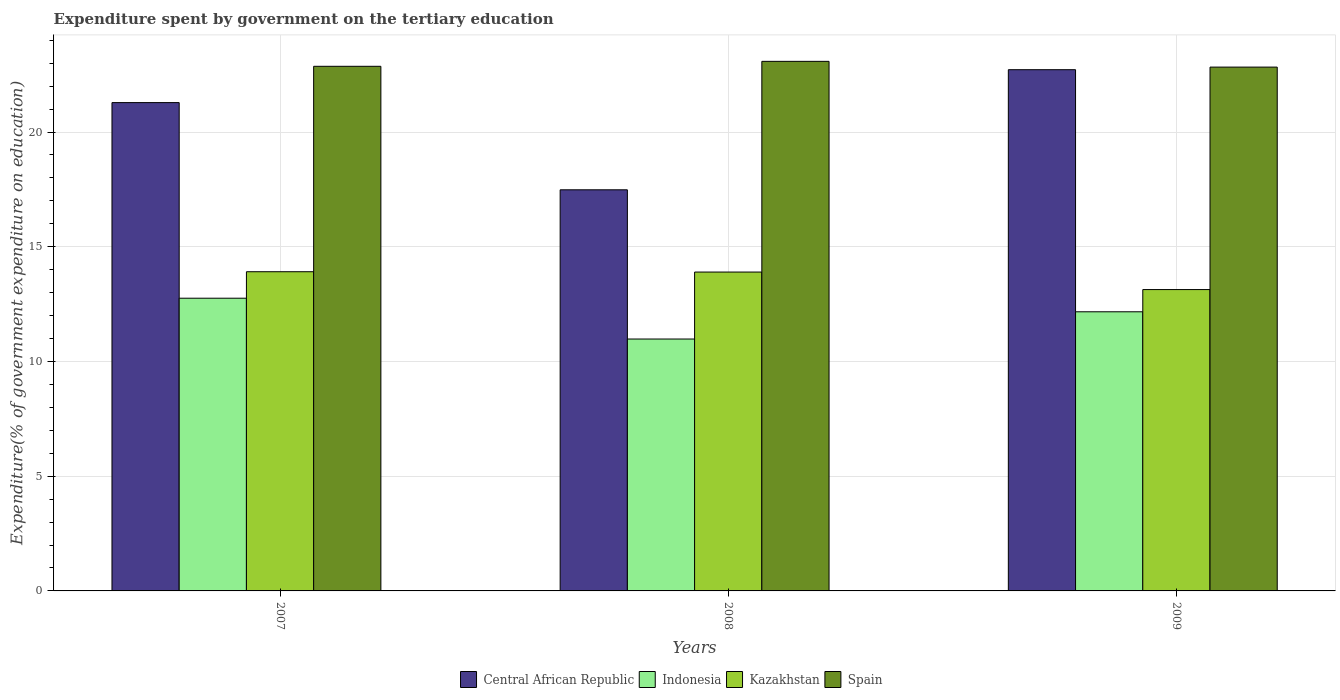How many different coloured bars are there?
Provide a short and direct response. 4. How many groups of bars are there?
Give a very brief answer. 3. Are the number of bars per tick equal to the number of legend labels?
Provide a short and direct response. Yes. Are the number of bars on each tick of the X-axis equal?
Provide a short and direct response. Yes. What is the label of the 2nd group of bars from the left?
Provide a short and direct response. 2008. What is the expenditure spent by government on the tertiary education in Spain in 2007?
Your answer should be very brief. 22.86. Across all years, what is the maximum expenditure spent by government on the tertiary education in Indonesia?
Your answer should be very brief. 12.76. Across all years, what is the minimum expenditure spent by government on the tertiary education in Kazakhstan?
Offer a terse response. 13.13. In which year was the expenditure spent by government on the tertiary education in Kazakhstan maximum?
Provide a succinct answer. 2007. In which year was the expenditure spent by government on the tertiary education in Spain minimum?
Provide a succinct answer. 2009. What is the total expenditure spent by government on the tertiary education in Spain in the graph?
Your answer should be very brief. 68.77. What is the difference between the expenditure spent by government on the tertiary education in Indonesia in 2007 and that in 2008?
Give a very brief answer. 1.78. What is the difference between the expenditure spent by government on the tertiary education in Kazakhstan in 2007 and the expenditure spent by government on the tertiary education in Spain in 2009?
Your answer should be compact. -8.92. What is the average expenditure spent by government on the tertiary education in Spain per year?
Your answer should be compact. 22.92. In the year 2009, what is the difference between the expenditure spent by government on the tertiary education in Indonesia and expenditure spent by government on the tertiary education in Spain?
Your answer should be very brief. -10.66. In how many years, is the expenditure spent by government on the tertiary education in Kazakhstan greater than 21 %?
Provide a succinct answer. 0. What is the ratio of the expenditure spent by government on the tertiary education in Spain in 2007 to that in 2009?
Offer a very short reply. 1. Is the expenditure spent by government on the tertiary education in Indonesia in 2008 less than that in 2009?
Your answer should be compact. Yes. Is the difference between the expenditure spent by government on the tertiary education in Indonesia in 2008 and 2009 greater than the difference between the expenditure spent by government on the tertiary education in Spain in 2008 and 2009?
Give a very brief answer. No. What is the difference between the highest and the second highest expenditure spent by government on the tertiary education in Spain?
Make the answer very short. 0.22. What is the difference between the highest and the lowest expenditure spent by government on the tertiary education in Central African Republic?
Your answer should be compact. 5.23. In how many years, is the expenditure spent by government on the tertiary education in Indonesia greater than the average expenditure spent by government on the tertiary education in Indonesia taken over all years?
Give a very brief answer. 2. Is the sum of the expenditure spent by government on the tertiary education in Spain in 2008 and 2009 greater than the maximum expenditure spent by government on the tertiary education in Central African Republic across all years?
Make the answer very short. Yes. Is it the case that in every year, the sum of the expenditure spent by government on the tertiary education in Kazakhstan and expenditure spent by government on the tertiary education in Spain is greater than the sum of expenditure spent by government on the tertiary education in Central African Republic and expenditure spent by government on the tertiary education in Indonesia?
Provide a short and direct response. No. What does the 4th bar from the left in 2008 represents?
Give a very brief answer. Spain. Are all the bars in the graph horizontal?
Your response must be concise. No. Does the graph contain any zero values?
Give a very brief answer. No. How many legend labels are there?
Keep it short and to the point. 4. How are the legend labels stacked?
Your answer should be very brief. Horizontal. What is the title of the graph?
Make the answer very short. Expenditure spent by government on the tertiary education. Does "Mexico" appear as one of the legend labels in the graph?
Your response must be concise. No. What is the label or title of the Y-axis?
Your answer should be compact. Expenditure(% of government expenditure on education). What is the Expenditure(% of government expenditure on education) in Central African Republic in 2007?
Give a very brief answer. 21.28. What is the Expenditure(% of government expenditure on education) of Indonesia in 2007?
Give a very brief answer. 12.76. What is the Expenditure(% of government expenditure on education) in Kazakhstan in 2007?
Offer a terse response. 13.91. What is the Expenditure(% of government expenditure on education) of Spain in 2007?
Offer a terse response. 22.86. What is the Expenditure(% of government expenditure on education) in Central African Republic in 2008?
Offer a very short reply. 17.48. What is the Expenditure(% of government expenditure on education) of Indonesia in 2008?
Provide a short and direct response. 10.98. What is the Expenditure(% of government expenditure on education) in Kazakhstan in 2008?
Make the answer very short. 13.9. What is the Expenditure(% of government expenditure on education) of Spain in 2008?
Your response must be concise. 23.08. What is the Expenditure(% of government expenditure on education) in Central African Republic in 2009?
Your answer should be very brief. 22.72. What is the Expenditure(% of government expenditure on education) in Indonesia in 2009?
Provide a short and direct response. 12.17. What is the Expenditure(% of government expenditure on education) of Kazakhstan in 2009?
Your response must be concise. 13.13. What is the Expenditure(% of government expenditure on education) in Spain in 2009?
Your response must be concise. 22.83. Across all years, what is the maximum Expenditure(% of government expenditure on education) in Central African Republic?
Keep it short and to the point. 22.72. Across all years, what is the maximum Expenditure(% of government expenditure on education) in Indonesia?
Offer a terse response. 12.76. Across all years, what is the maximum Expenditure(% of government expenditure on education) in Kazakhstan?
Provide a short and direct response. 13.91. Across all years, what is the maximum Expenditure(% of government expenditure on education) in Spain?
Give a very brief answer. 23.08. Across all years, what is the minimum Expenditure(% of government expenditure on education) of Central African Republic?
Give a very brief answer. 17.48. Across all years, what is the minimum Expenditure(% of government expenditure on education) in Indonesia?
Keep it short and to the point. 10.98. Across all years, what is the minimum Expenditure(% of government expenditure on education) in Kazakhstan?
Ensure brevity in your answer.  13.13. Across all years, what is the minimum Expenditure(% of government expenditure on education) in Spain?
Offer a terse response. 22.83. What is the total Expenditure(% of government expenditure on education) of Central African Republic in the graph?
Provide a short and direct response. 61.48. What is the total Expenditure(% of government expenditure on education) in Indonesia in the graph?
Your answer should be very brief. 35.9. What is the total Expenditure(% of government expenditure on education) of Kazakhstan in the graph?
Ensure brevity in your answer.  40.94. What is the total Expenditure(% of government expenditure on education) in Spain in the graph?
Give a very brief answer. 68.77. What is the difference between the Expenditure(% of government expenditure on education) of Central African Republic in 2007 and that in 2008?
Offer a very short reply. 3.8. What is the difference between the Expenditure(% of government expenditure on education) in Indonesia in 2007 and that in 2008?
Provide a short and direct response. 1.78. What is the difference between the Expenditure(% of government expenditure on education) of Kazakhstan in 2007 and that in 2008?
Offer a terse response. 0.01. What is the difference between the Expenditure(% of government expenditure on education) of Spain in 2007 and that in 2008?
Your response must be concise. -0.22. What is the difference between the Expenditure(% of government expenditure on education) in Central African Republic in 2007 and that in 2009?
Ensure brevity in your answer.  -1.43. What is the difference between the Expenditure(% of government expenditure on education) of Indonesia in 2007 and that in 2009?
Your answer should be very brief. 0.59. What is the difference between the Expenditure(% of government expenditure on education) of Kazakhstan in 2007 and that in 2009?
Keep it short and to the point. 0.78. What is the difference between the Expenditure(% of government expenditure on education) in Spain in 2007 and that in 2009?
Make the answer very short. 0.03. What is the difference between the Expenditure(% of government expenditure on education) in Central African Republic in 2008 and that in 2009?
Make the answer very short. -5.23. What is the difference between the Expenditure(% of government expenditure on education) of Indonesia in 2008 and that in 2009?
Your answer should be very brief. -1.19. What is the difference between the Expenditure(% of government expenditure on education) of Kazakhstan in 2008 and that in 2009?
Keep it short and to the point. 0.76. What is the difference between the Expenditure(% of government expenditure on education) of Spain in 2008 and that in 2009?
Your answer should be very brief. 0.25. What is the difference between the Expenditure(% of government expenditure on education) in Central African Republic in 2007 and the Expenditure(% of government expenditure on education) in Indonesia in 2008?
Ensure brevity in your answer.  10.3. What is the difference between the Expenditure(% of government expenditure on education) in Central African Republic in 2007 and the Expenditure(% of government expenditure on education) in Kazakhstan in 2008?
Ensure brevity in your answer.  7.39. What is the difference between the Expenditure(% of government expenditure on education) of Central African Republic in 2007 and the Expenditure(% of government expenditure on education) of Spain in 2008?
Offer a very short reply. -1.8. What is the difference between the Expenditure(% of government expenditure on education) in Indonesia in 2007 and the Expenditure(% of government expenditure on education) in Kazakhstan in 2008?
Offer a very short reply. -1.14. What is the difference between the Expenditure(% of government expenditure on education) of Indonesia in 2007 and the Expenditure(% of government expenditure on education) of Spain in 2008?
Keep it short and to the point. -10.32. What is the difference between the Expenditure(% of government expenditure on education) of Kazakhstan in 2007 and the Expenditure(% of government expenditure on education) of Spain in 2008?
Keep it short and to the point. -9.17. What is the difference between the Expenditure(% of government expenditure on education) in Central African Republic in 2007 and the Expenditure(% of government expenditure on education) in Indonesia in 2009?
Keep it short and to the point. 9.12. What is the difference between the Expenditure(% of government expenditure on education) of Central African Republic in 2007 and the Expenditure(% of government expenditure on education) of Kazakhstan in 2009?
Keep it short and to the point. 8.15. What is the difference between the Expenditure(% of government expenditure on education) in Central African Republic in 2007 and the Expenditure(% of government expenditure on education) in Spain in 2009?
Provide a succinct answer. -1.55. What is the difference between the Expenditure(% of government expenditure on education) of Indonesia in 2007 and the Expenditure(% of government expenditure on education) of Kazakhstan in 2009?
Your answer should be very brief. -0.38. What is the difference between the Expenditure(% of government expenditure on education) of Indonesia in 2007 and the Expenditure(% of government expenditure on education) of Spain in 2009?
Offer a terse response. -10.07. What is the difference between the Expenditure(% of government expenditure on education) of Kazakhstan in 2007 and the Expenditure(% of government expenditure on education) of Spain in 2009?
Offer a terse response. -8.92. What is the difference between the Expenditure(% of government expenditure on education) of Central African Republic in 2008 and the Expenditure(% of government expenditure on education) of Indonesia in 2009?
Keep it short and to the point. 5.32. What is the difference between the Expenditure(% of government expenditure on education) in Central African Republic in 2008 and the Expenditure(% of government expenditure on education) in Kazakhstan in 2009?
Your answer should be very brief. 4.35. What is the difference between the Expenditure(% of government expenditure on education) of Central African Republic in 2008 and the Expenditure(% of government expenditure on education) of Spain in 2009?
Offer a very short reply. -5.35. What is the difference between the Expenditure(% of government expenditure on education) in Indonesia in 2008 and the Expenditure(% of government expenditure on education) in Kazakhstan in 2009?
Provide a succinct answer. -2.16. What is the difference between the Expenditure(% of government expenditure on education) in Indonesia in 2008 and the Expenditure(% of government expenditure on education) in Spain in 2009?
Your answer should be compact. -11.85. What is the difference between the Expenditure(% of government expenditure on education) of Kazakhstan in 2008 and the Expenditure(% of government expenditure on education) of Spain in 2009?
Your response must be concise. -8.93. What is the average Expenditure(% of government expenditure on education) of Central African Republic per year?
Provide a succinct answer. 20.49. What is the average Expenditure(% of government expenditure on education) of Indonesia per year?
Offer a very short reply. 11.97. What is the average Expenditure(% of government expenditure on education) in Kazakhstan per year?
Give a very brief answer. 13.65. What is the average Expenditure(% of government expenditure on education) in Spain per year?
Make the answer very short. 22.92. In the year 2007, what is the difference between the Expenditure(% of government expenditure on education) of Central African Republic and Expenditure(% of government expenditure on education) of Indonesia?
Make the answer very short. 8.53. In the year 2007, what is the difference between the Expenditure(% of government expenditure on education) in Central African Republic and Expenditure(% of government expenditure on education) in Kazakhstan?
Give a very brief answer. 7.37. In the year 2007, what is the difference between the Expenditure(% of government expenditure on education) in Central African Republic and Expenditure(% of government expenditure on education) in Spain?
Keep it short and to the point. -1.58. In the year 2007, what is the difference between the Expenditure(% of government expenditure on education) in Indonesia and Expenditure(% of government expenditure on education) in Kazakhstan?
Your answer should be very brief. -1.15. In the year 2007, what is the difference between the Expenditure(% of government expenditure on education) of Indonesia and Expenditure(% of government expenditure on education) of Spain?
Keep it short and to the point. -10.11. In the year 2007, what is the difference between the Expenditure(% of government expenditure on education) of Kazakhstan and Expenditure(% of government expenditure on education) of Spain?
Ensure brevity in your answer.  -8.95. In the year 2008, what is the difference between the Expenditure(% of government expenditure on education) of Central African Republic and Expenditure(% of government expenditure on education) of Indonesia?
Make the answer very short. 6.5. In the year 2008, what is the difference between the Expenditure(% of government expenditure on education) in Central African Republic and Expenditure(% of government expenditure on education) in Kazakhstan?
Give a very brief answer. 3.59. In the year 2008, what is the difference between the Expenditure(% of government expenditure on education) in Central African Republic and Expenditure(% of government expenditure on education) in Spain?
Offer a terse response. -5.6. In the year 2008, what is the difference between the Expenditure(% of government expenditure on education) of Indonesia and Expenditure(% of government expenditure on education) of Kazakhstan?
Give a very brief answer. -2.92. In the year 2008, what is the difference between the Expenditure(% of government expenditure on education) of Indonesia and Expenditure(% of government expenditure on education) of Spain?
Your answer should be compact. -12.1. In the year 2008, what is the difference between the Expenditure(% of government expenditure on education) of Kazakhstan and Expenditure(% of government expenditure on education) of Spain?
Your answer should be very brief. -9.18. In the year 2009, what is the difference between the Expenditure(% of government expenditure on education) in Central African Republic and Expenditure(% of government expenditure on education) in Indonesia?
Offer a terse response. 10.55. In the year 2009, what is the difference between the Expenditure(% of government expenditure on education) in Central African Republic and Expenditure(% of government expenditure on education) in Kazakhstan?
Make the answer very short. 9.58. In the year 2009, what is the difference between the Expenditure(% of government expenditure on education) in Central African Republic and Expenditure(% of government expenditure on education) in Spain?
Keep it short and to the point. -0.11. In the year 2009, what is the difference between the Expenditure(% of government expenditure on education) in Indonesia and Expenditure(% of government expenditure on education) in Kazakhstan?
Provide a succinct answer. -0.97. In the year 2009, what is the difference between the Expenditure(% of government expenditure on education) in Indonesia and Expenditure(% of government expenditure on education) in Spain?
Ensure brevity in your answer.  -10.66. In the year 2009, what is the difference between the Expenditure(% of government expenditure on education) of Kazakhstan and Expenditure(% of government expenditure on education) of Spain?
Keep it short and to the point. -9.7. What is the ratio of the Expenditure(% of government expenditure on education) of Central African Republic in 2007 to that in 2008?
Make the answer very short. 1.22. What is the ratio of the Expenditure(% of government expenditure on education) in Indonesia in 2007 to that in 2008?
Keep it short and to the point. 1.16. What is the ratio of the Expenditure(% of government expenditure on education) of Spain in 2007 to that in 2008?
Your answer should be compact. 0.99. What is the ratio of the Expenditure(% of government expenditure on education) in Central African Republic in 2007 to that in 2009?
Provide a short and direct response. 0.94. What is the ratio of the Expenditure(% of government expenditure on education) of Indonesia in 2007 to that in 2009?
Make the answer very short. 1.05. What is the ratio of the Expenditure(% of government expenditure on education) of Kazakhstan in 2007 to that in 2009?
Offer a terse response. 1.06. What is the ratio of the Expenditure(% of government expenditure on education) of Central African Republic in 2008 to that in 2009?
Make the answer very short. 0.77. What is the ratio of the Expenditure(% of government expenditure on education) in Indonesia in 2008 to that in 2009?
Provide a succinct answer. 0.9. What is the ratio of the Expenditure(% of government expenditure on education) in Kazakhstan in 2008 to that in 2009?
Provide a short and direct response. 1.06. What is the ratio of the Expenditure(% of government expenditure on education) of Spain in 2008 to that in 2009?
Keep it short and to the point. 1.01. What is the difference between the highest and the second highest Expenditure(% of government expenditure on education) of Central African Republic?
Keep it short and to the point. 1.43. What is the difference between the highest and the second highest Expenditure(% of government expenditure on education) in Indonesia?
Your answer should be very brief. 0.59. What is the difference between the highest and the second highest Expenditure(% of government expenditure on education) in Kazakhstan?
Your response must be concise. 0.01. What is the difference between the highest and the second highest Expenditure(% of government expenditure on education) in Spain?
Give a very brief answer. 0.22. What is the difference between the highest and the lowest Expenditure(% of government expenditure on education) in Central African Republic?
Offer a very short reply. 5.23. What is the difference between the highest and the lowest Expenditure(% of government expenditure on education) in Indonesia?
Ensure brevity in your answer.  1.78. What is the difference between the highest and the lowest Expenditure(% of government expenditure on education) of Kazakhstan?
Offer a terse response. 0.78. What is the difference between the highest and the lowest Expenditure(% of government expenditure on education) in Spain?
Provide a short and direct response. 0.25. 